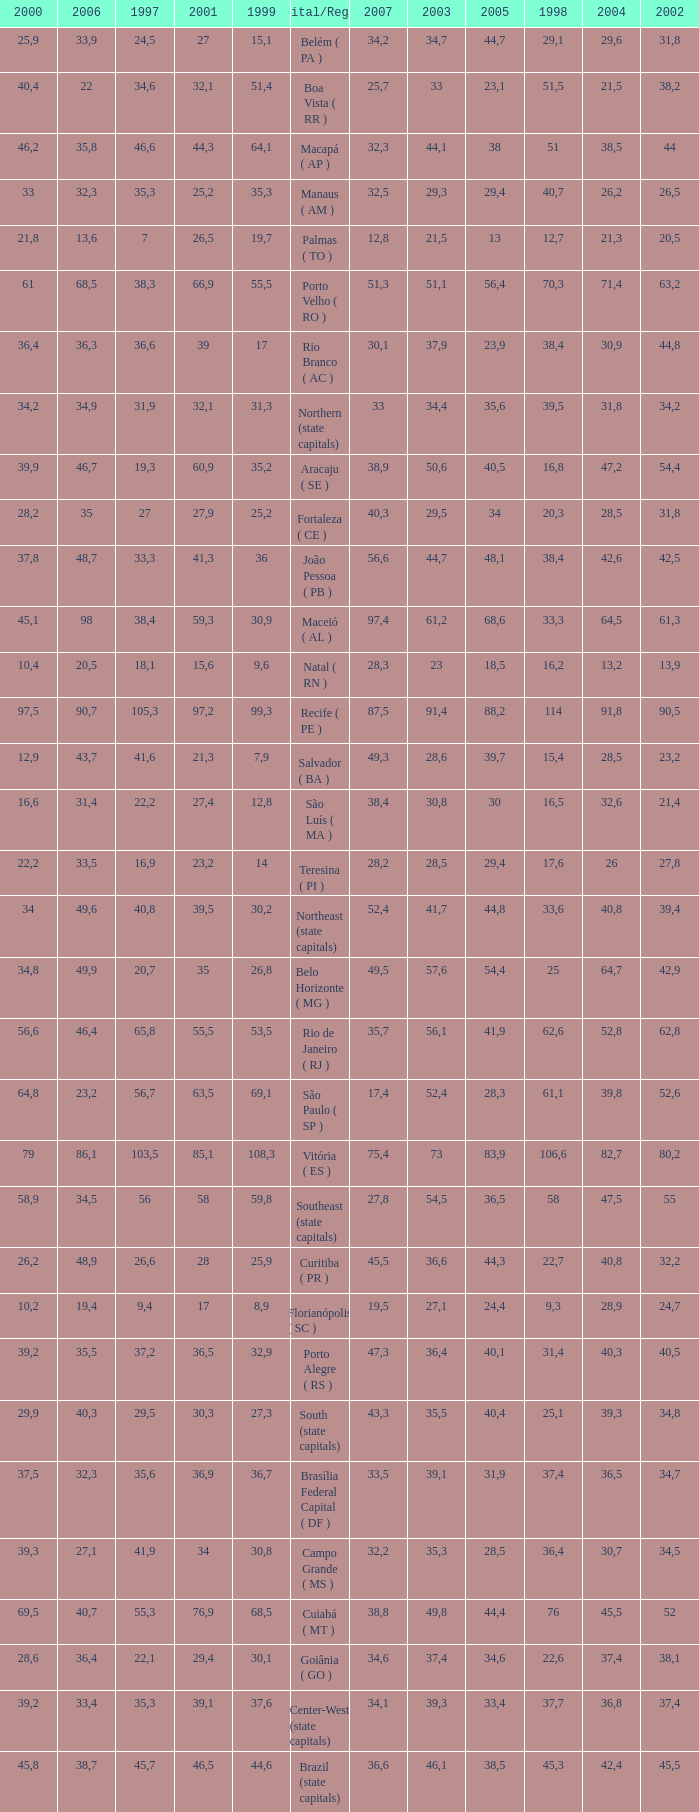How many 2007's have a 2003 less than 36,4, 27,9 as a 2001, and a 1999 less than 25,2? None. 